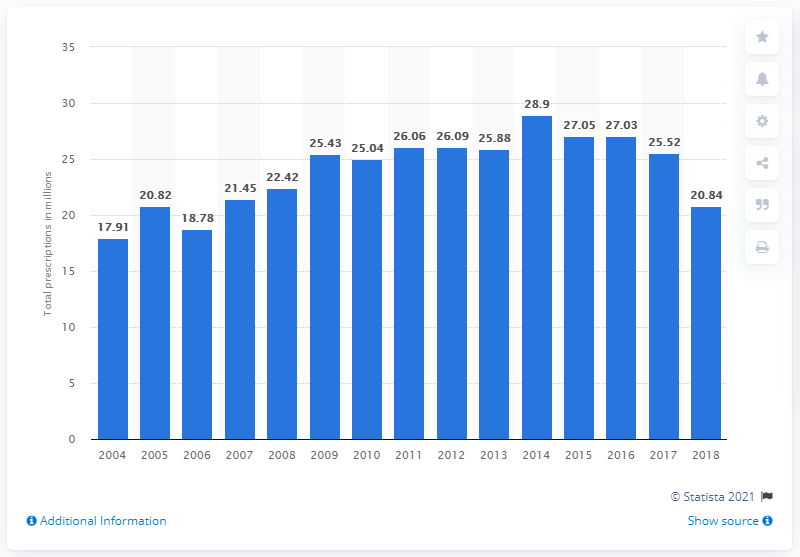Identify some key points in this picture. In 2004, a total of 17,910 prescriptions for alprazolam were dispensed. In 2018, there were 20,823 prescriptions written for alprazolam, a sedative medication used to treat anxiety disorders. 